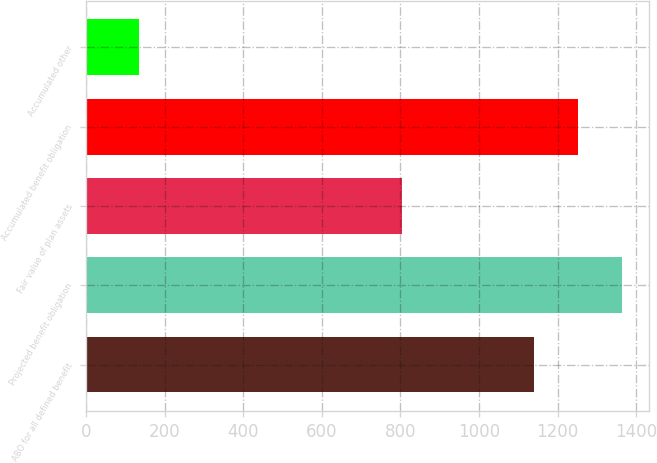<chart> <loc_0><loc_0><loc_500><loc_500><bar_chart><fcel>ABO for all defined benefit<fcel>Projected benefit obligation<fcel>Fair value of plan assets<fcel>Accumulated benefit obligation<fcel>Accumulated other<nl><fcel>1139.1<fcel>1364.16<fcel>804.6<fcel>1251.63<fcel>133.6<nl></chart> 